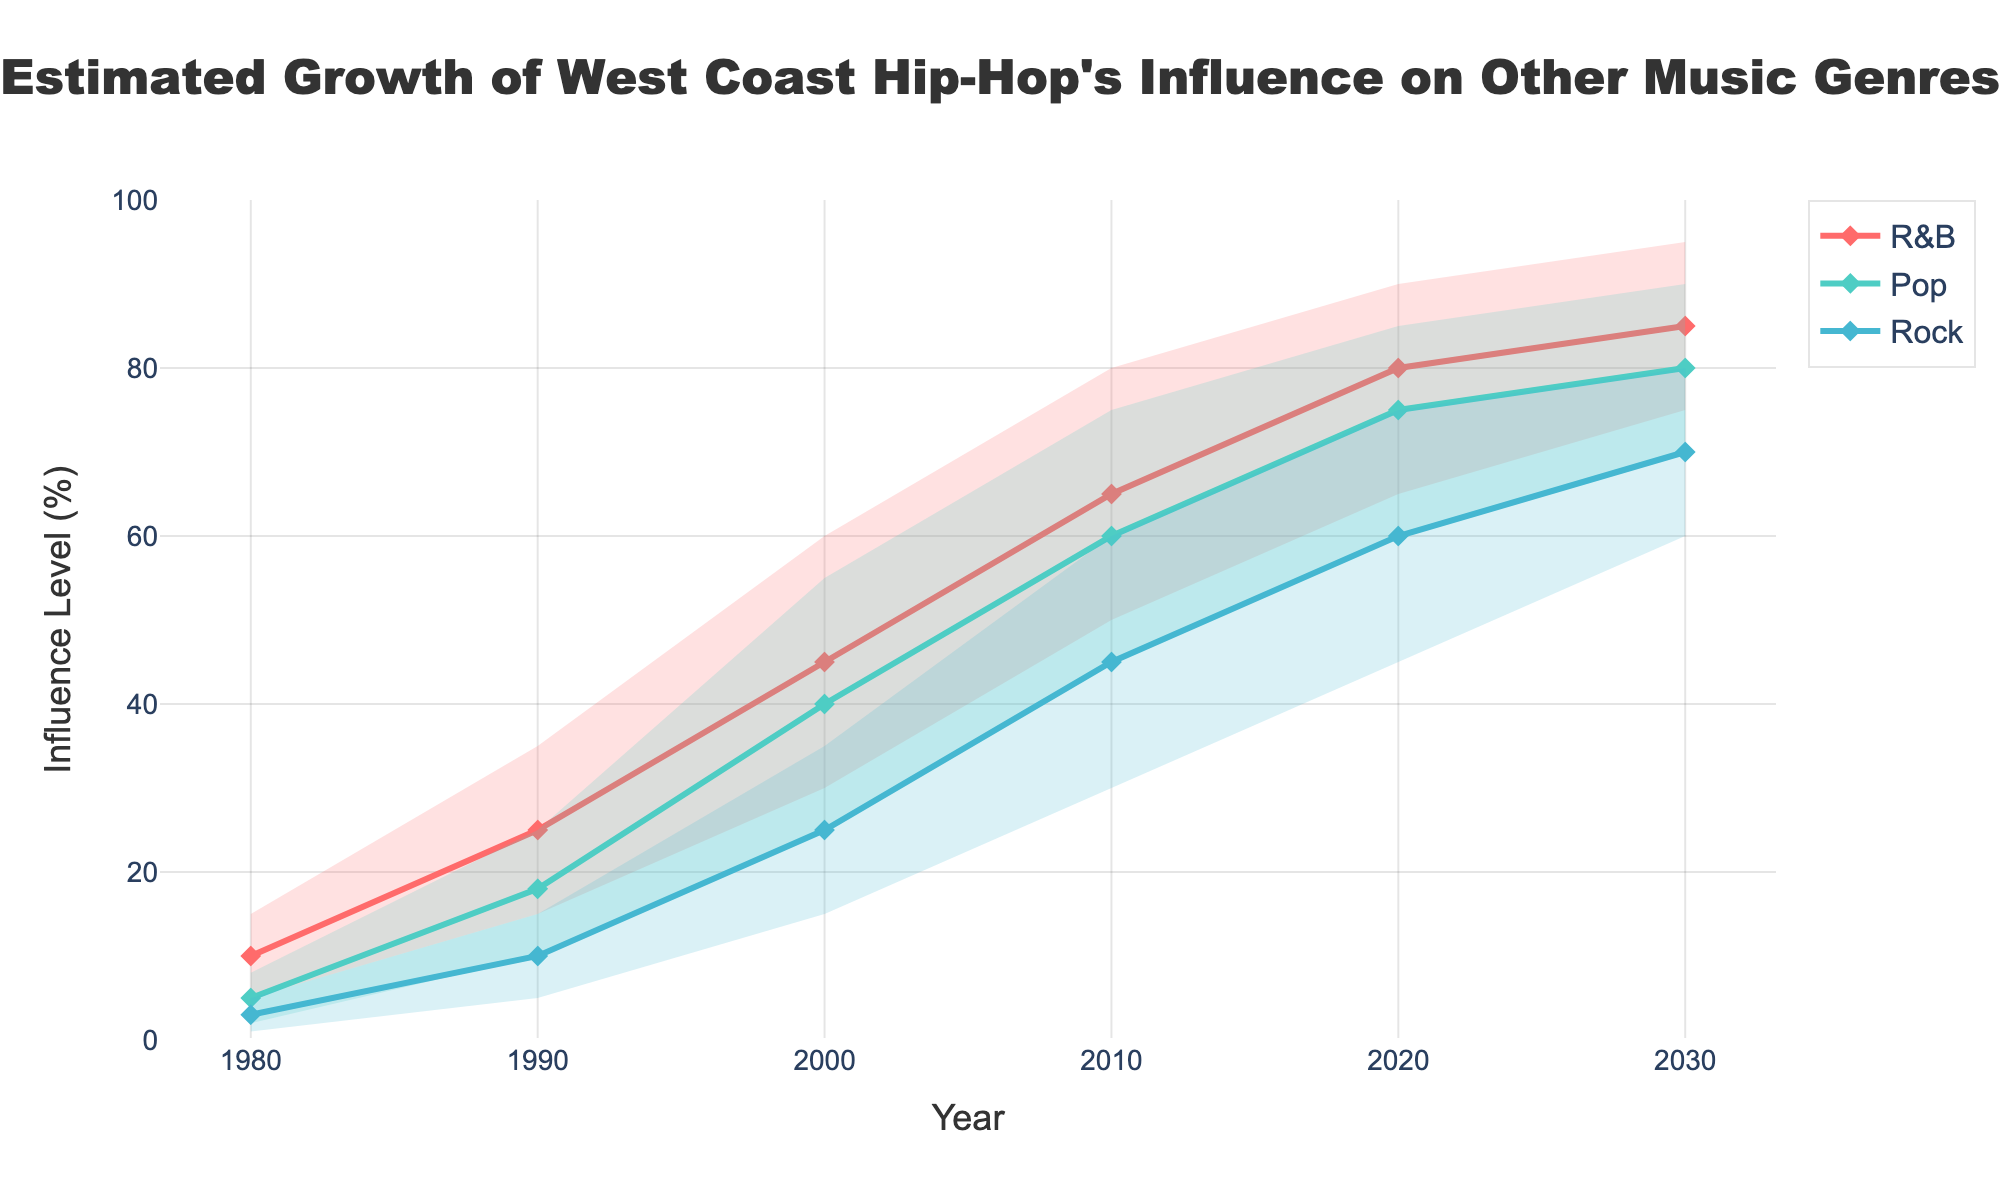What is the title of the figure? The title is displayed at the top center of the figure.
Answer: Estimated Growth of West Coast Hip-Hop's Influence on Other Music Genres Between which years is West-Coast hip-hop’s influence on Pop expected to grow the most? Compare the increase in Mid values of Pop from one timeframe to another. The largest increase occurs between the years 1980 and 1990 (from 5 to 18, an increase of 13) and 2000 and 2010 (from 40 to 60, an increase of 20). The latter is the largest growth period.
Answer: 2000 and 2010 What is the range of West-Coast hip-hop's influence on R&B in 2030? Look at the Low and High values for R&B in 2030. They are 75 and 95, respectively. Subtract the Low from the High.
Answer: 20 Among the three genres, which has the highest projected Mid influence level in 2030? Compare the Mid values for all three genres in 2030: R&B (85), Pop (80), and Rock (70). The highest Mid value is for R&B.
Answer: R&B What color represents the influence of West-Coast hip-hop on Pop? Identify the color of the lines and filled areas corresponding to Pop data.
Answer: Green (#4ECDC4) Which genre shows the smallest range of influence in 2020? Compare the ranges (High - Low) for each genre in 2020: R&B (90-65=25), Pop (85-60=25), Rock (75-45=30). Pop and R&B have the same smallest range.
Answer: Pop and R&B What is the average influence level of West-Coast hip-hop on Rock in 2010? Average the Low (30), Mid (45), and High (60) values for Rock in 2010: (30+45+60) / 3 = 45.
Answer: 45 Does any genre show a consistent increase in influence over all time periods? Check each genre's Mid values across all years to see if they consistently increase. R&B, Pop, and Rock all show consistent increases.
Answer: Yes, all genres How does the influence of West-Coast hip-hop on R&B in 1990 compare to its influence on Rock in the same year? Compare the Mid values for R&B and Rock in 1990: R&B is 25 and Rock is 10. R&B has a higher influence.
Answer: R&B has a higher influence Calculate the total increase in Mid influence level for Pop from 1980 to 2030. Subtract the Mid value in 1980 (5) from the Mid value in 2030 (80): 80 - 5 = 75.
Answer: 75 